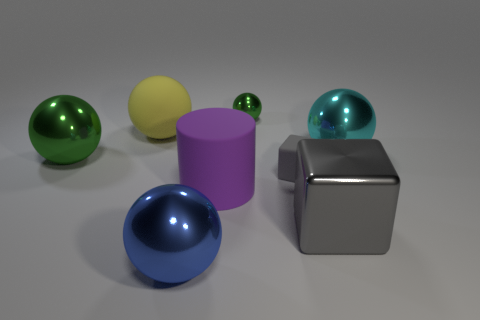What is the color of the smallest sphere in the image? The smallest sphere in the image is green. It has a reflective surface, similar to some of the larger spheres. 